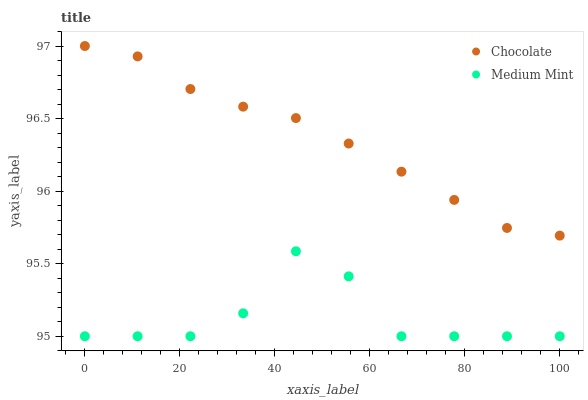Does Medium Mint have the minimum area under the curve?
Answer yes or no. Yes. Does Chocolate have the maximum area under the curve?
Answer yes or no. Yes. Does Chocolate have the minimum area under the curve?
Answer yes or no. No. Is Chocolate the smoothest?
Answer yes or no. Yes. Is Medium Mint the roughest?
Answer yes or no. Yes. Is Chocolate the roughest?
Answer yes or no. No. Does Medium Mint have the lowest value?
Answer yes or no. Yes. Does Chocolate have the lowest value?
Answer yes or no. No. Does Chocolate have the highest value?
Answer yes or no. Yes. Is Medium Mint less than Chocolate?
Answer yes or no. Yes. Is Chocolate greater than Medium Mint?
Answer yes or no. Yes. Does Medium Mint intersect Chocolate?
Answer yes or no. No. 